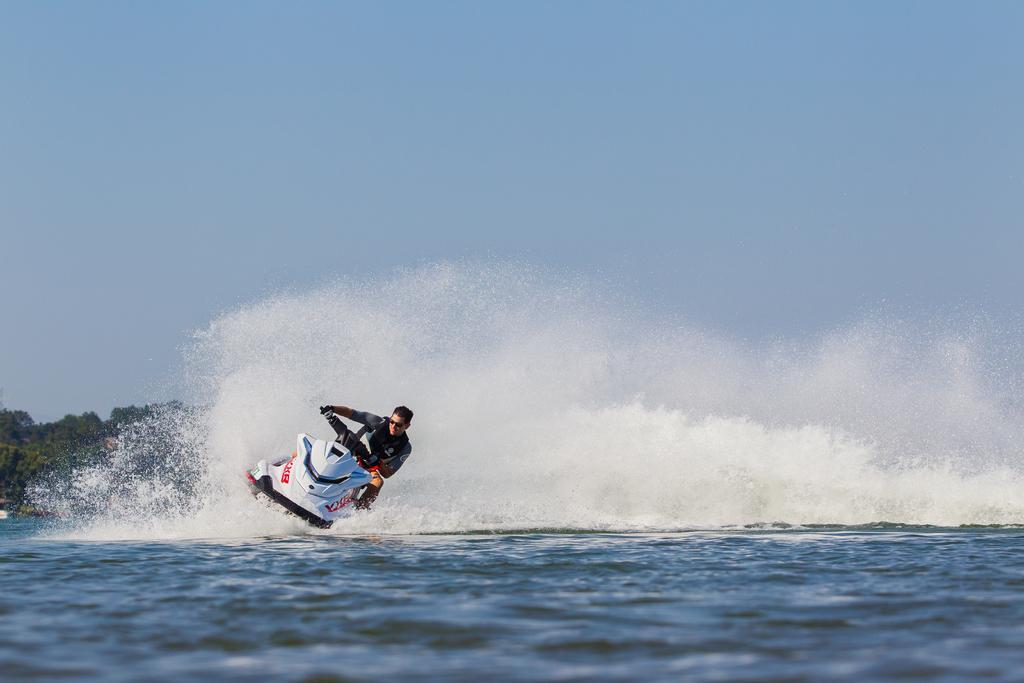How would you summarize this image in a sentence or two? This is the picture of a sea. In this image there is a person riding water bike on the water. At the back there are trees. At the top there is sky. At the bottom there is water. 